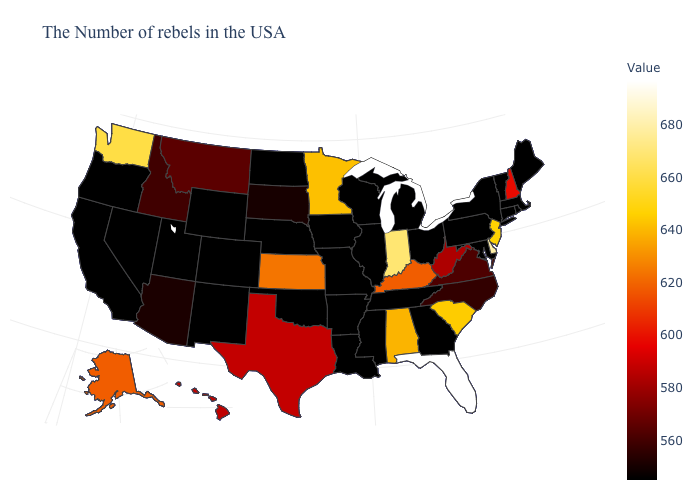Which states have the highest value in the USA?
Concise answer only. Florida. Among the states that border Massachusetts , which have the highest value?
Keep it brief. New Hampshire. Is the legend a continuous bar?
Keep it brief. Yes. Does Wisconsin have a lower value than Kansas?
Be succinct. Yes. 